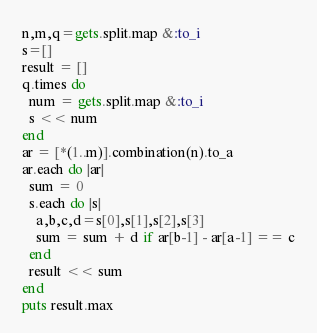<code> <loc_0><loc_0><loc_500><loc_500><_Ruby_>n,m,q=gets.split.map &:to_i
s=[]
result = []
q.times do
  num = gets.split.map &:to_i
  s << num
end
ar = [*(1..m)].combination(n).to_a
ar.each do |ar|
  sum = 0
  s.each do |s|
    a,b,c,d=s[0],s[1],s[2],s[3]
    sum = sum + d if ar[b-1] - ar[a-1] == c
  end
  result << sum
end
puts result.max</code> 